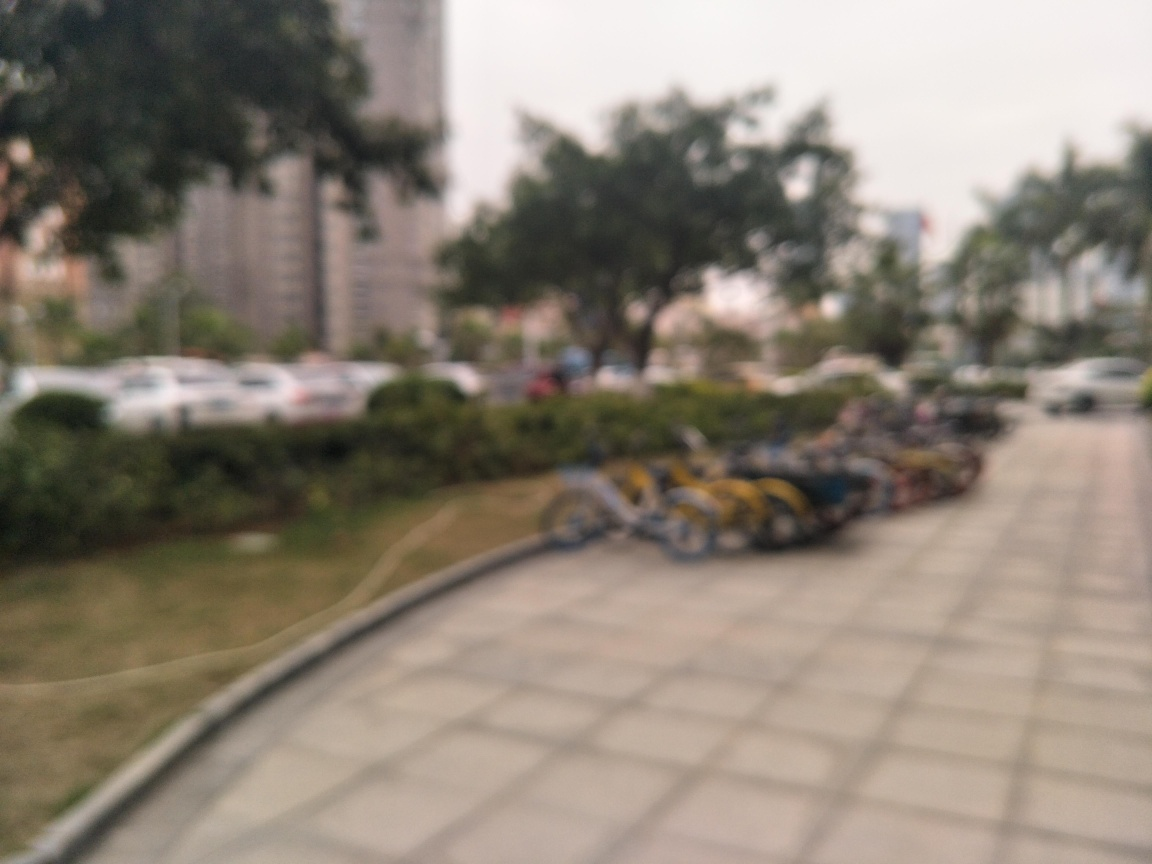What is the clarity of this image?
A. poor
B. good
C. average
Answer with the option's letter from the given choices directly.
 A. 